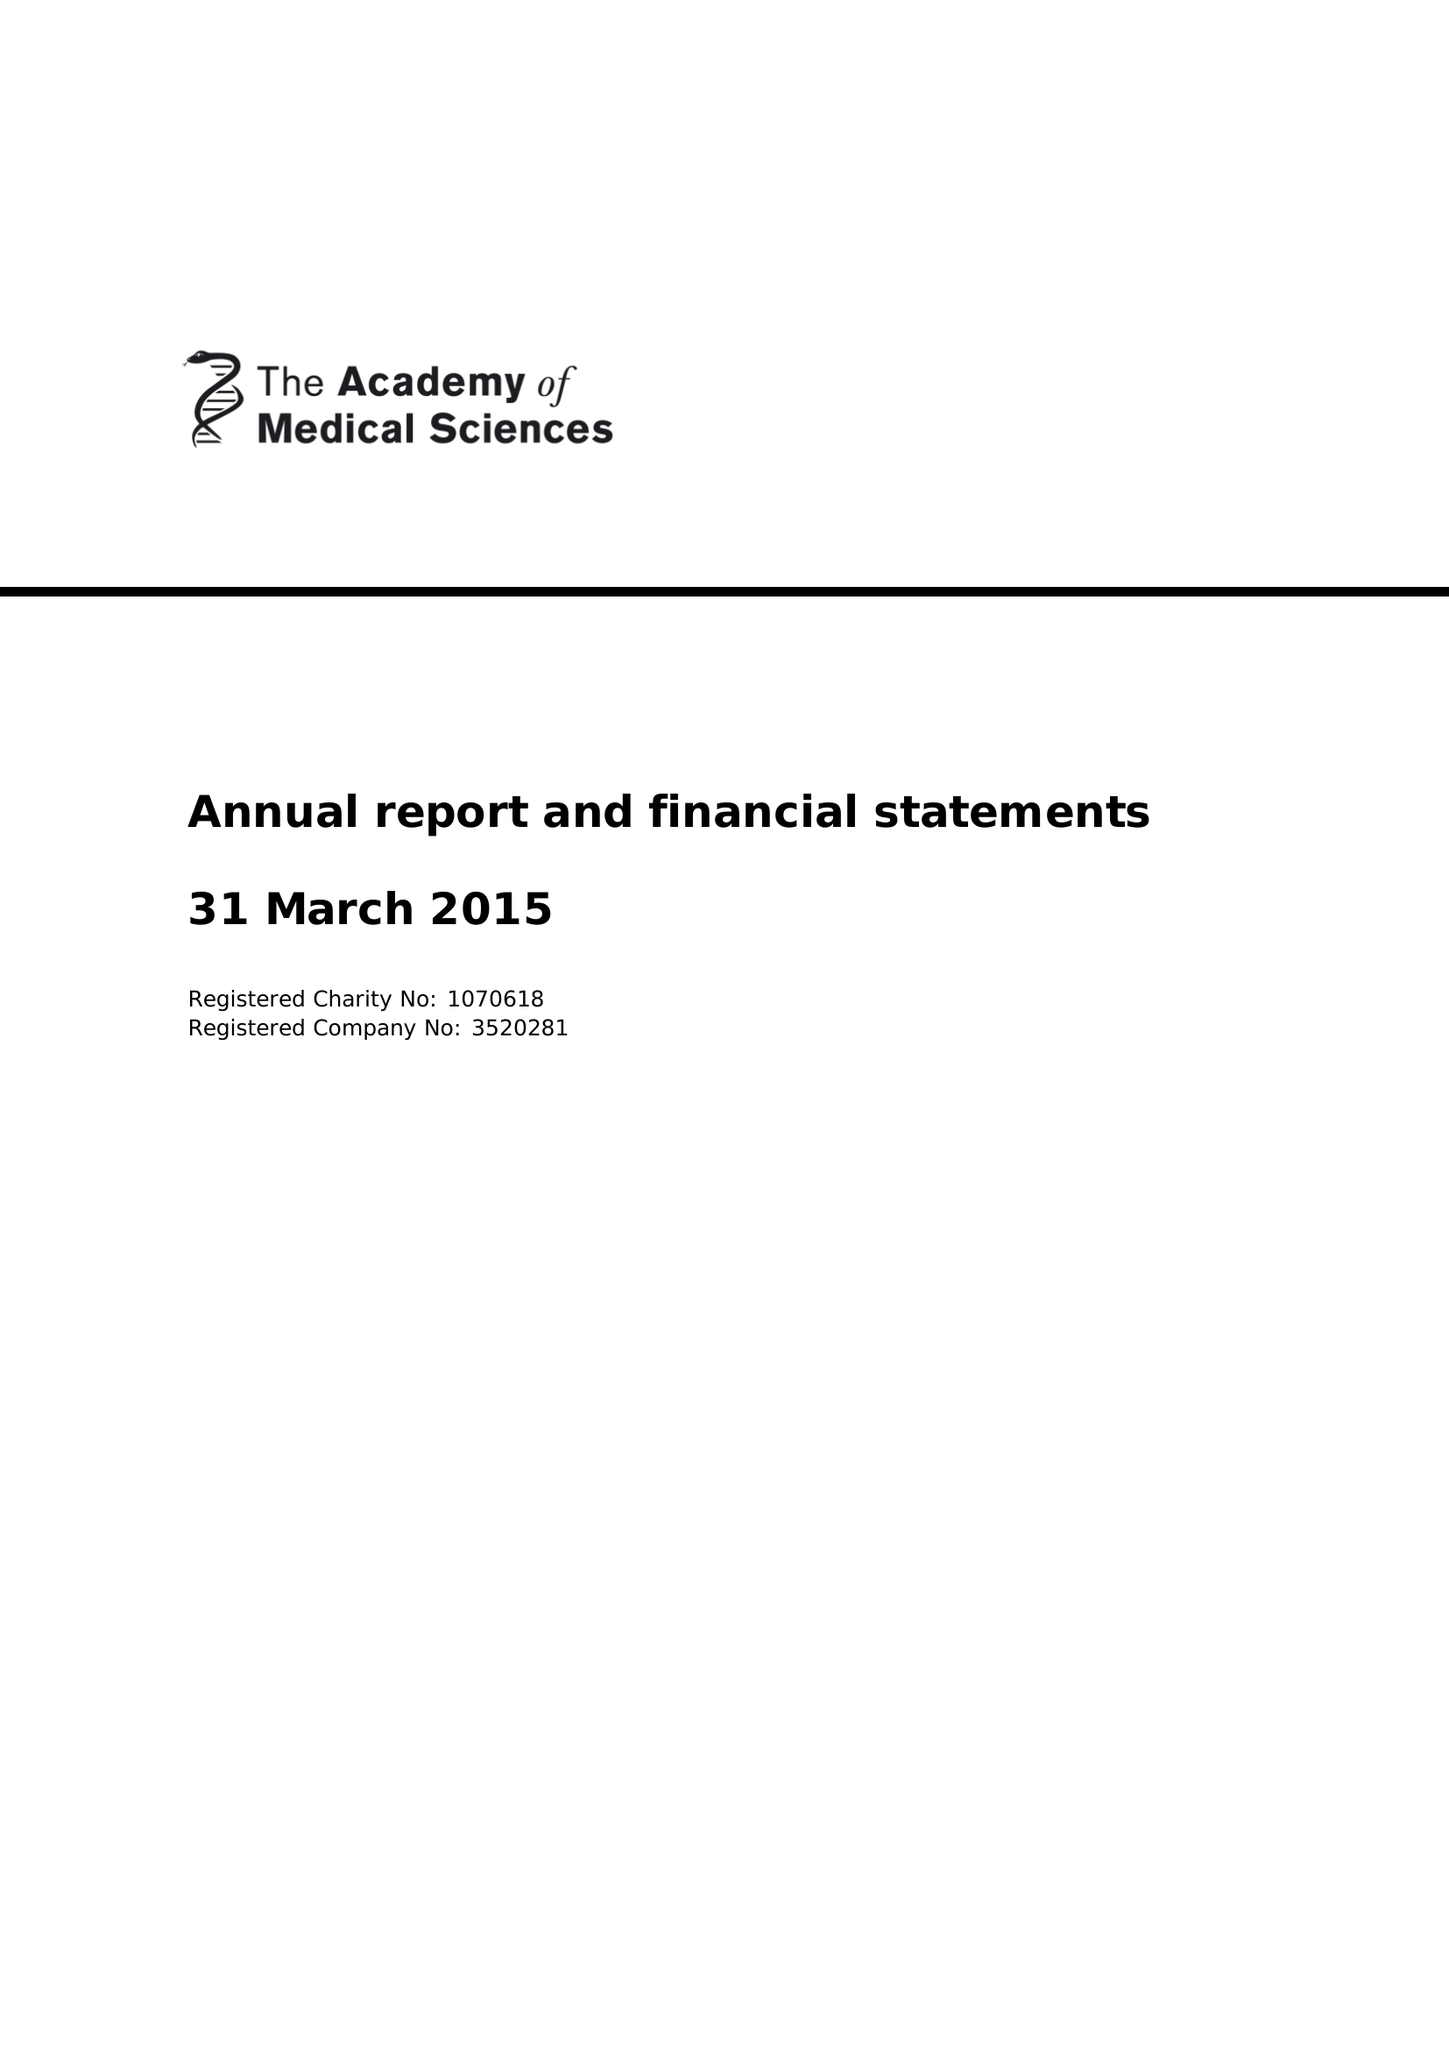What is the value for the charity_name?
Answer the question using a single word or phrase. Academy Of Medical Sciences 